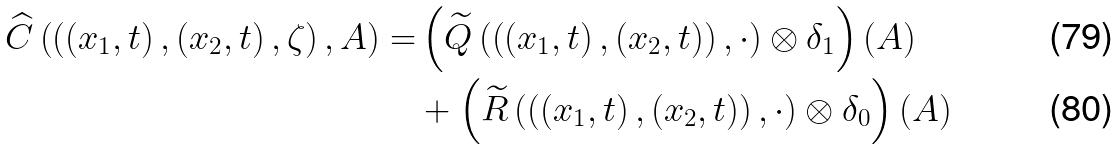<formula> <loc_0><loc_0><loc_500><loc_500>\widehat { C } \left ( \left ( \left ( x _ { 1 } , t \right ) , \left ( x _ { 2 } , t \right ) , \zeta \right ) , A \right ) = & \left ( \widetilde { Q } \left ( \left ( \left ( x _ { 1 } , t \right ) , \left ( x _ { 2 } , t \right ) \right ) , \cdot \right ) \otimes \delta _ { 1 } \right ) ( A ) \\ & + \left ( \widetilde { R } \left ( \left ( \left ( x _ { 1 } , t \right ) , \left ( x _ { 2 } , t \right ) \right ) , \cdot \right ) \otimes \delta _ { 0 } \right ) ( A )</formula> 